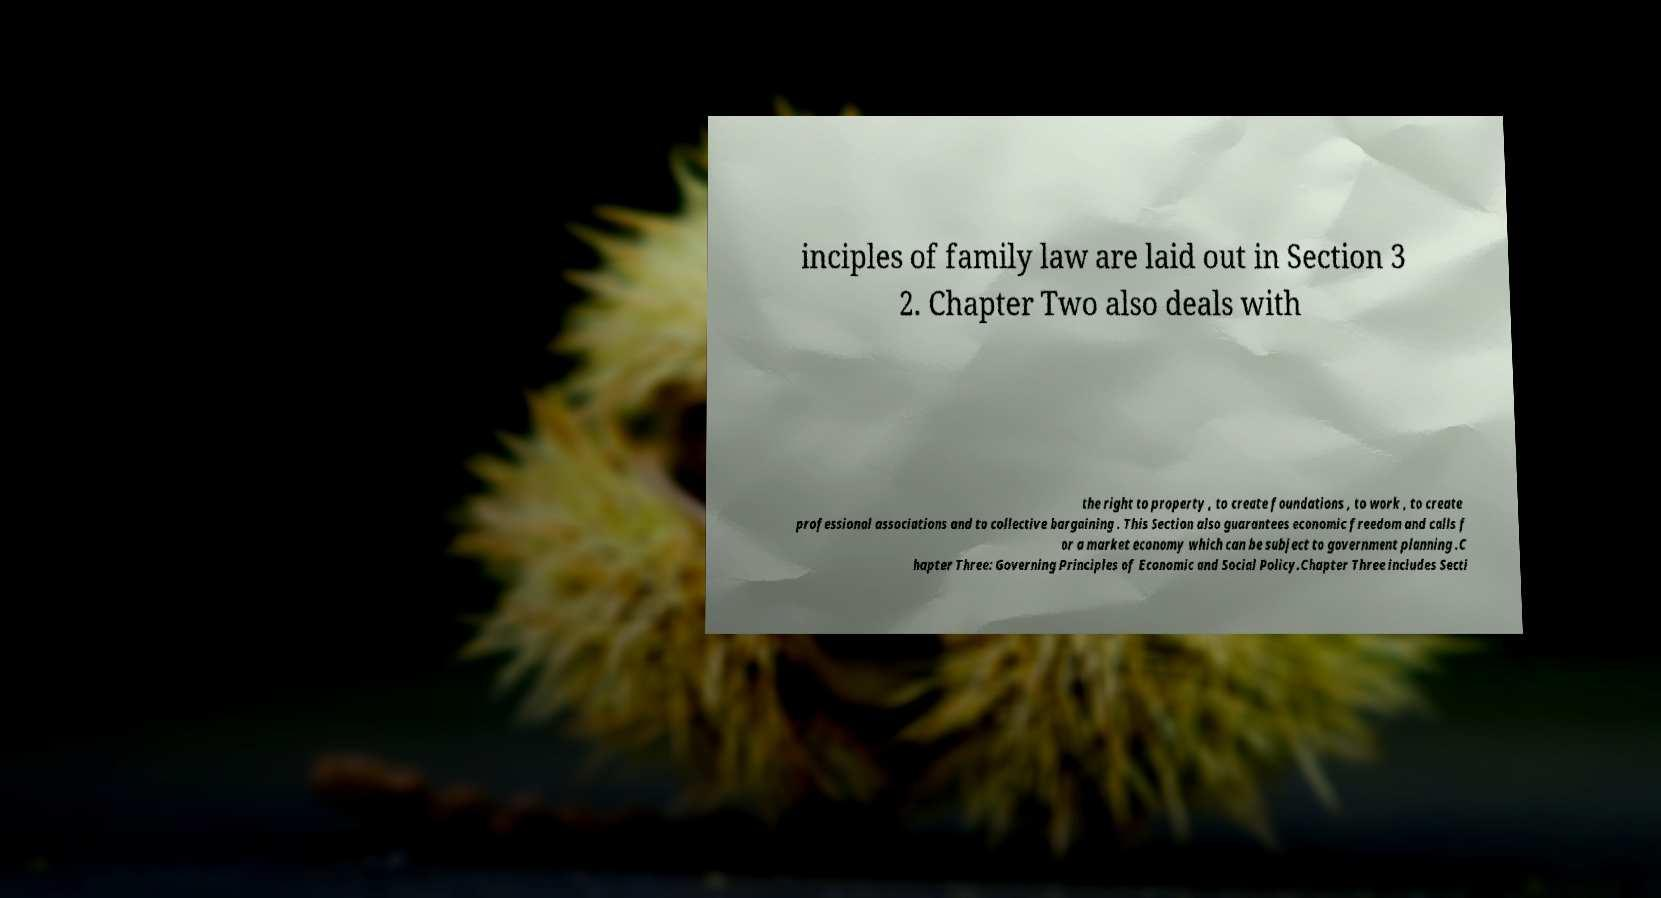For documentation purposes, I need the text within this image transcribed. Could you provide that? inciples of family law are laid out in Section 3 2. Chapter Two also deals with the right to property , to create foundations , to work , to create professional associations and to collective bargaining . This Section also guarantees economic freedom and calls f or a market economy which can be subject to government planning .C hapter Three: Governing Principles of Economic and Social Policy.Chapter Three includes Secti 